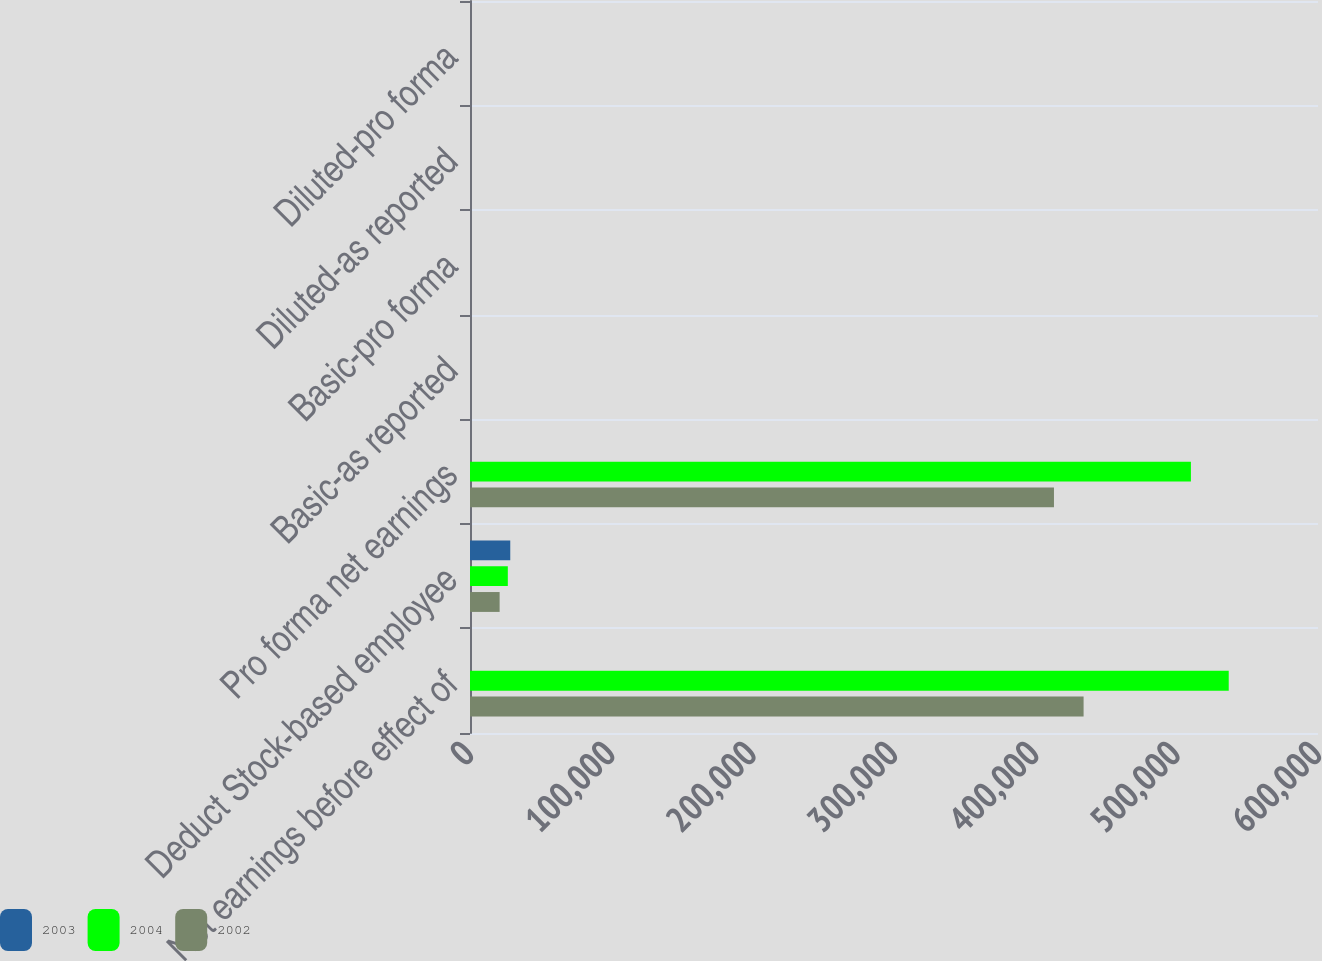Convert chart to OTSL. <chart><loc_0><loc_0><loc_500><loc_500><stacked_bar_chart><ecel><fcel>Net earnings before effect of<fcel>Deduct Stock-based employee<fcel>Pro forma net earnings<fcel>Basic-as reported<fcel>Basic-pro forma<fcel>Diluted-as reported<fcel>Diluted-pro forma<nl><fcel>2003<fcel>2.3<fcel>28487<fcel>2.3<fcel>2.41<fcel>2.32<fcel>2.3<fcel>2.22<nl><fcel>2004<fcel>536834<fcel>26755<fcel>510079<fcel>1.75<fcel>1.66<fcel>1.69<fcel>1.6<nl><fcel>2002<fcel>434141<fcel>20960<fcel>413181<fcel>1.45<fcel>1.38<fcel>1.39<fcel>1.33<nl></chart> 